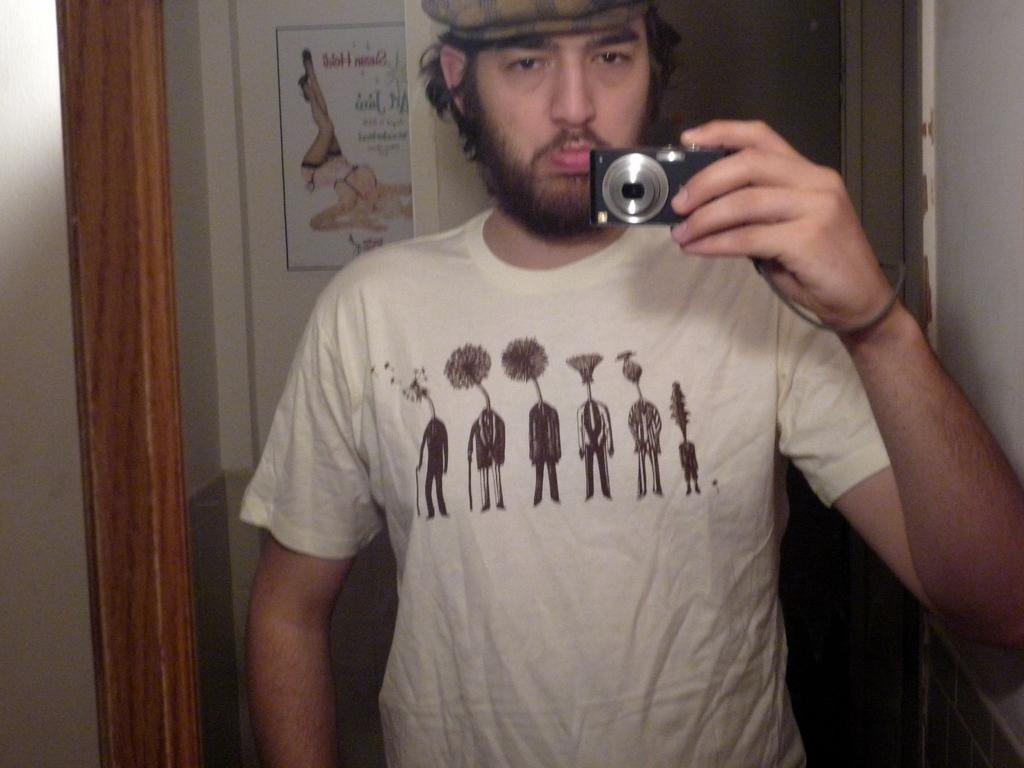What is the main subject of the image? There is a man in the image. What is the man doing in the image? The man is standing in the image. What is the man holding in the image? The man is holding a camera in the image. What is the man wearing on his head in the image? The man is wearing a cap in the image. What is the man wearing on his upper body in the image? The man is wearing a white t-shirt in the image. What can be seen on the wall in the image? There is a poster on the wall in the image. What color is the curtain in the image? The curtain is orange in color in the image. How many kittens are sitting on the man's shoulders in the image? There are no kittens present in the image. What type of mass is being conducted in the image? There is no mass being conducted in the image. What kind of treatment is the man receiving in the image? There is no treatment being administered in the image. 